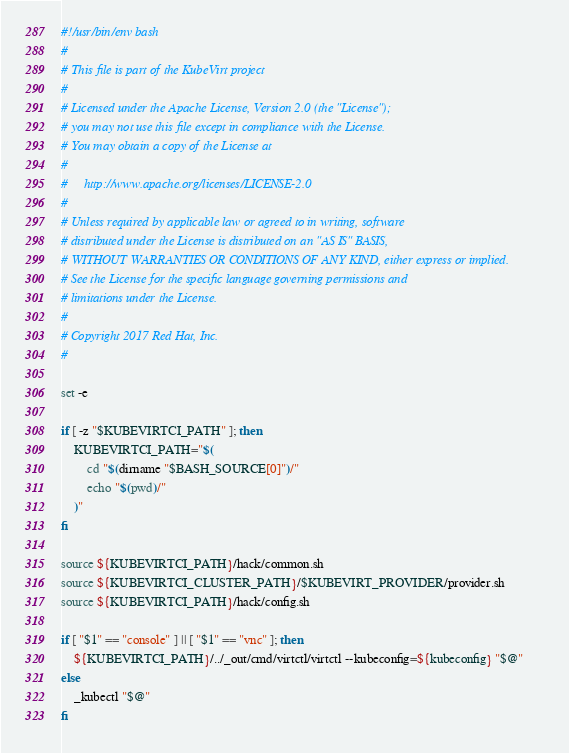<code> <loc_0><loc_0><loc_500><loc_500><_Bash_>#!/usr/bin/env bash
#
# This file is part of the KubeVirt project
#
# Licensed under the Apache License, Version 2.0 (the "License");
# you may not use this file except in compliance with the License.
# You may obtain a copy of the License at
#
#     http://www.apache.org/licenses/LICENSE-2.0
#
# Unless required by applicable law or agreed to in writing, software
# distributed under the License is distributed on an "AS IS" BASIS,
# WITHOUT WARRANTIES OR CONDITIONS OF ANY KIND, either express or implied.
# See the License for the specific language governing permissions and
# limitations under the License.
#
# Copyright 2017 Red Hat, Inc.
#

set -e

if [ -z "$KUBEVIRTCI_PATH" ]; then
    KUBEVIRTCI_PATH="$(
        cd "$(dirname "$BASH_SOURCE[0]")/"
        echo "$(pwd)/"
    )"
fi

source ${KUBEVIRTCI_PATH}/hack/common.sh
source ${KUBEVIRTCI_CLUSTER_PATH}/$KUBEVIRT_PROVIDER/provider.sh
source ${KUBEVIRTCI_PATH}/hack/config.sh

if [ "$1" == "console" ] || [ "$1" == "vnc" ]; then
    ${KUBEVIRTCI_PATH}/../_out/cmd/virtctl/virtctl --kubeconfig=${kubeconfig} "$@"
else
    _kubectl "$@"
fi

</code> 